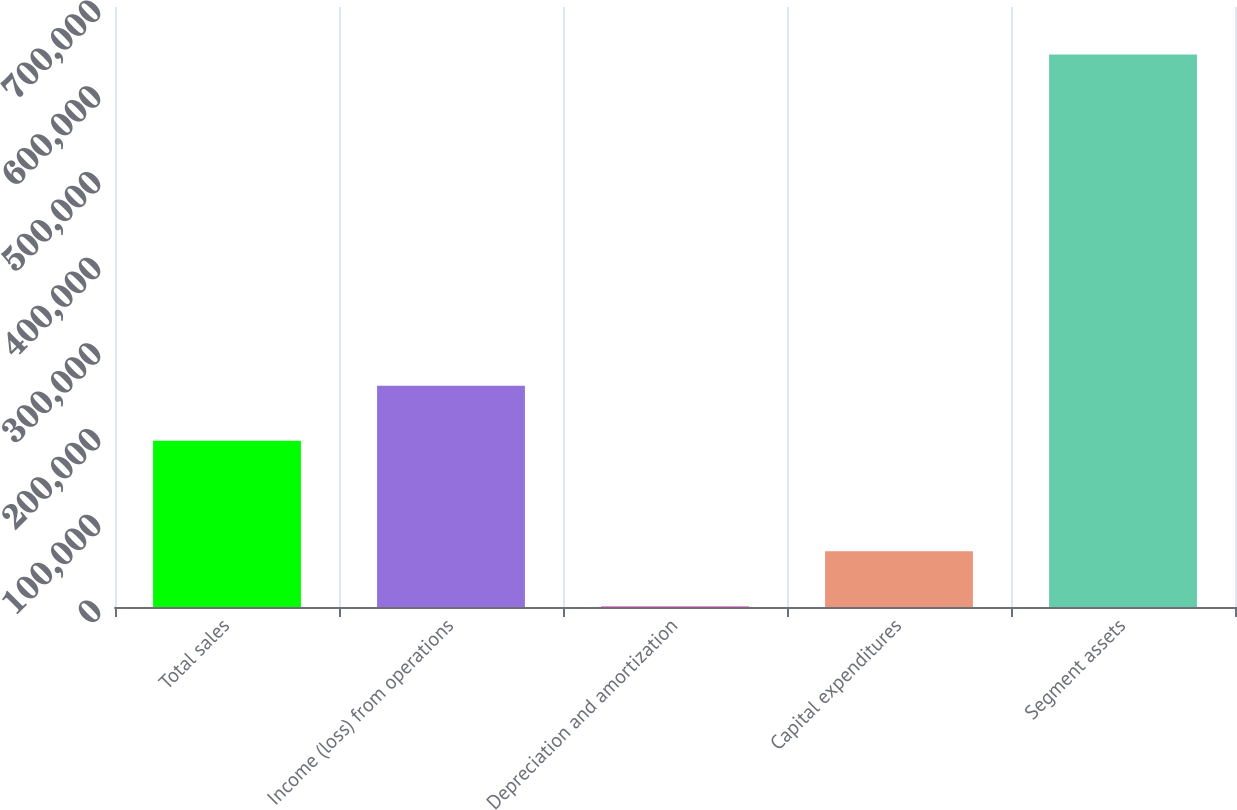Convert chart to OTSL. <chart><loc_0><loc_0><loc_500><loc_500><bar_chart><fcel>Total sales<fcel>Income (loss) from operations<fcel>Depreciation and amortization<fcel>Capital expenditures<fcel>Segment assets<nl><fcel>193860<fcel>258257<fcel>670<fcel>65066.7<fcel>644637<nl></chart> 